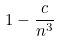<formula> <loc_0><loc_0><loc_500><loc_500>1 - \frac { c } { n ^ { 3 } }</formula> 